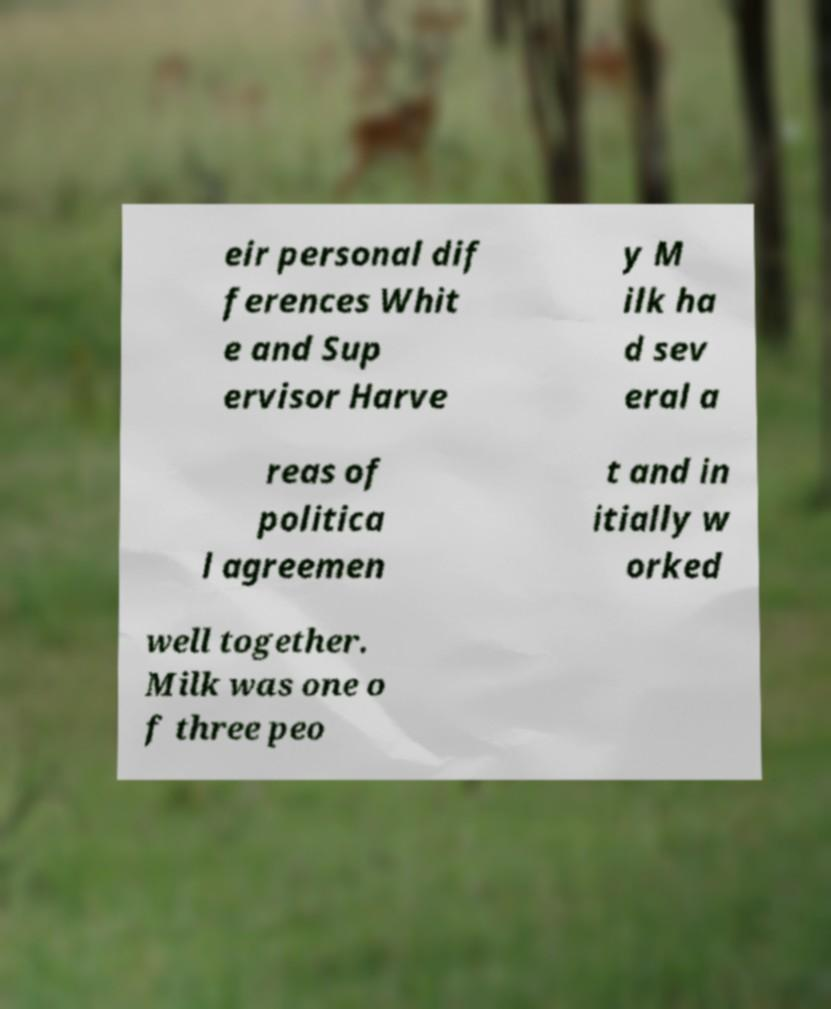What messages or text are displayed in this image? I need them in a readable, typed format. eir personal dif ferences Whit e and Sup ervisor Harve y M ilk ha d sev eral a reas of politica l agreemen t and in itially w orked well together. Milk was one o f three peo 